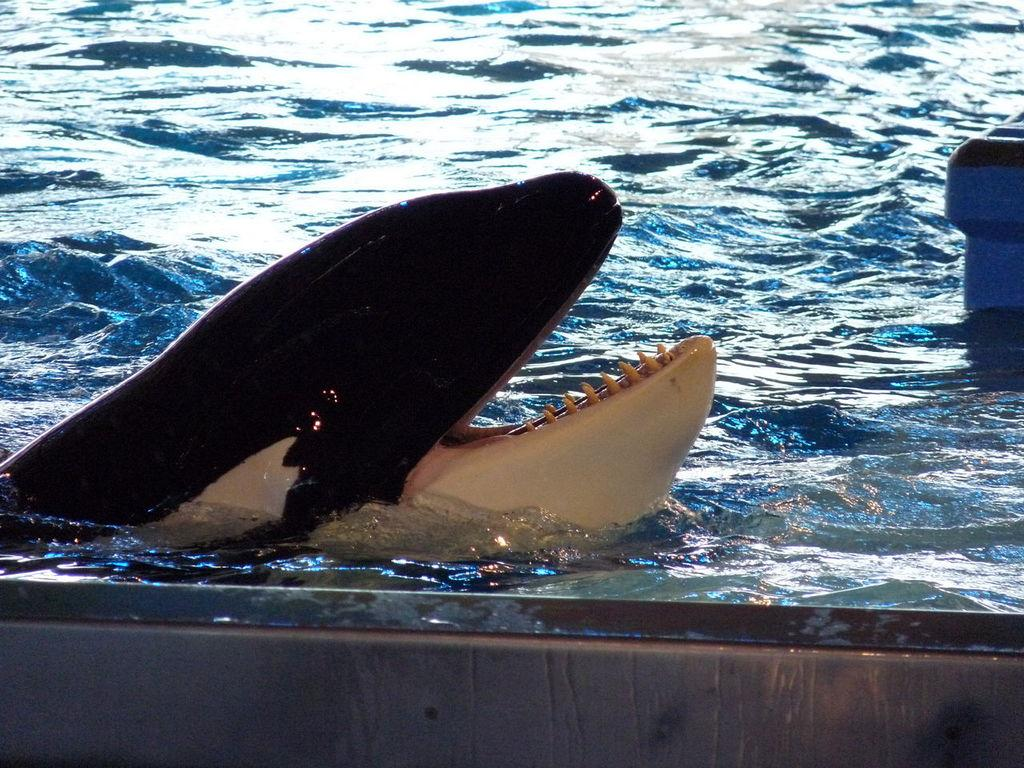What is present in the image? There is water visible in the image, and there is a sea animal present. Can you describe the sea animal in the image? Unfortunately, the specific type of sea animal cannot be determined from the provided facts. What is the primary setting of the image? The primary setting of the image is water. How many pizzas are floating in the water in the image? There are no pizzas present in the image; it features water and a sea animal. What type of zephyr can be seen blowing through the image? There is no mention of a zephyr in the provided facts, and therefore it cannot be determined if one is present in the image. 